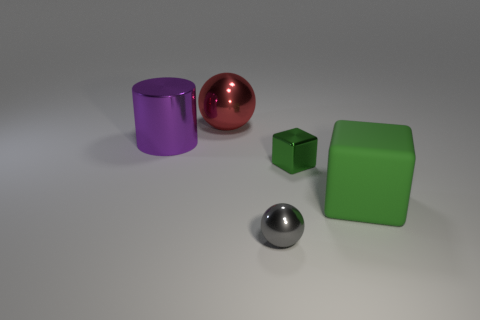Is there a big purple thing that is left of the ball that is in front of the matte cube?
Give a very brief answer. Yes. Does the sphere that is on the right side of the large red sphere have the same material as the big green object?
Provide a succinct answer. No. How many metal things are both on the right side of the large purple cylinder and behind the gray sphere?
Keep it short and to the point. 2. How many other things have the same material as the gray thing?
Keep it short and to the point. 3. There is a tiny ball that is the same material as the tiny cube; what color is it?
Offer a terse response. Gray. Are there fewer big green blocks than big metal things?
Make the answer very short. Yes. The big object to the right of the shiny ball right of the ball that is behind the small green metal block is made of what material?
Make the answer very short. Rubber. What is the material of the large green block?
Your response must be concise. Rubber. There is a large thing that is to the right of the large red metal thing; is it the same color as the tiny metal object that is behind the big matte thing?
Your answer should be compact. Yes. Are there more small cubes than small green cylinders?
Provide a short and direct response. Yes. 